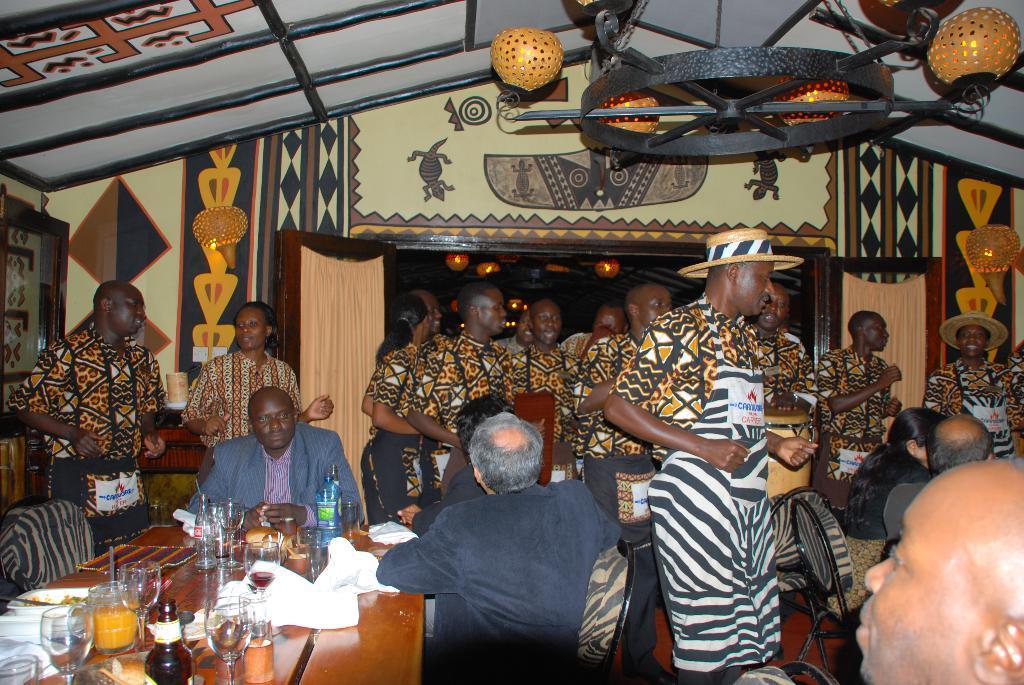Describe this image in one or two sentences. In this picture we can see the group of men wearing costumes dress and standing in the middle. In the front there are two men, sitting on the chair and watching to them. On the top there is a hanging chandelier and roof tent. 